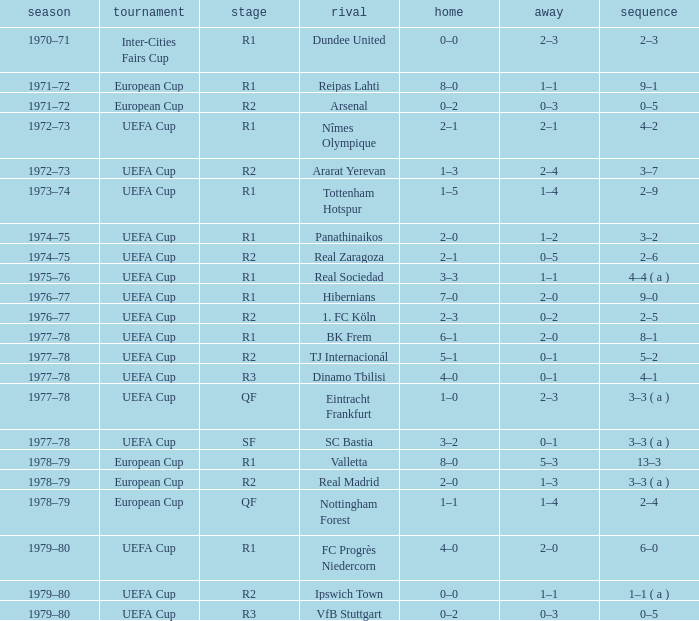Which Home has a Round of r1, and an Opponent of dundee united? 0–0. 